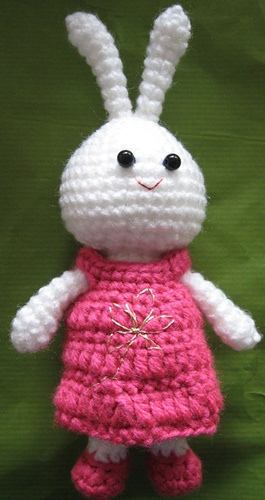<image>
Is there a blouse behind the chicken? No. The blouse is not behind the chicken. From this viewpoint, the blouse appears to be positioned elsewhere in the scene. 